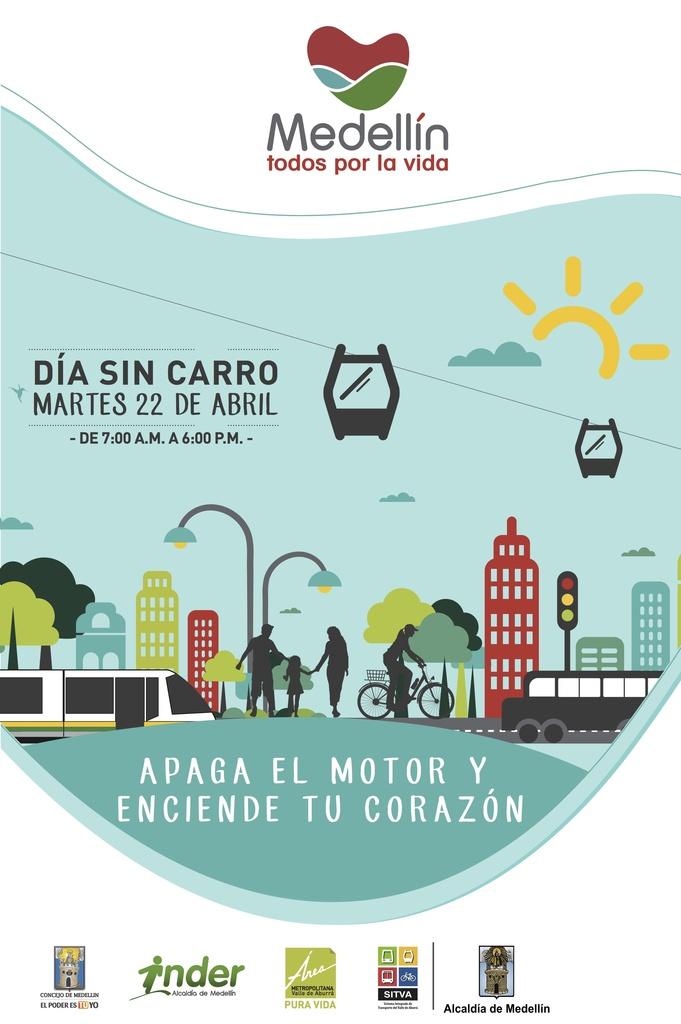What is the company name at the top?
Provide a succinct answer. Medellin. What are they advertising?
Your answer should be compact. Medellin. 